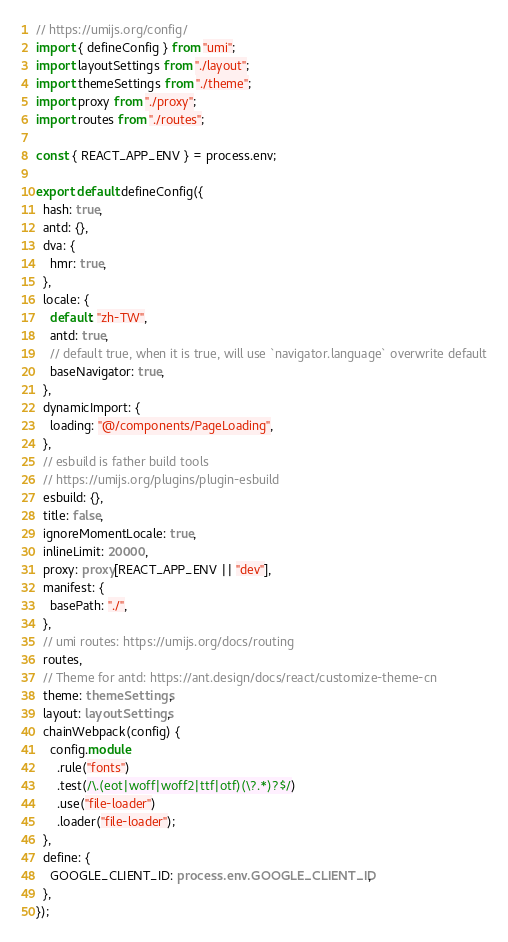Convert code to text. <code><loc_0><loc_0><loc_500><loc_500><_TypeScript_>// https://umijs.org/config/
import { defineConfig } from "umi";
import layoutSettings from "./layout";
import themeSettings from "./theme";
import proxy from "./proxy";
import routes from "./routes";

const { REACT_APP_ENV } = process.env;

export default defineConfig({
  hash: true,
  antd: {},
  dva: {
    hmr: true,
  },
  locale: {
    default: "zh-TW",
    antd: true,
    // default true, when it is true, will use `navigator.language` overwrite default
    baseNavigator: true,
  },
  dynamicImport: {
    loading: "@/components/PageLoading",
  },
  // esbuild is father build tools
  // https://umijs.org/plugins/plugin-esbuild
  esbuild: {},
  title: false,
  ignoreMomentLocale: true,
  inlineLimit: 20000,
  proxy: proxy[REACT_APP_ENV || "dev"],
  manifest: {
    basePath: "./",
  },
  // umi routes: https://umijs.org/docs/routing
  routes,
  // Theme for antd: https://ant.design/docs/react/customize-theme-cn
  theme: themeSettings,
  layout: layoutSettings,
  chainWebpack(config) {
    config.module
      .rule("fonts")
      .test(/\.(eot|woff|woff2|ttf|otf)(\?.*)?$/)
      .use("file-loader")
      .loader("file-loader");
  },
  define: {
    GOOGLE_CLIENT_ID: process.env.GOOGLE_CLIENT_ID,
  },
});
</code> 